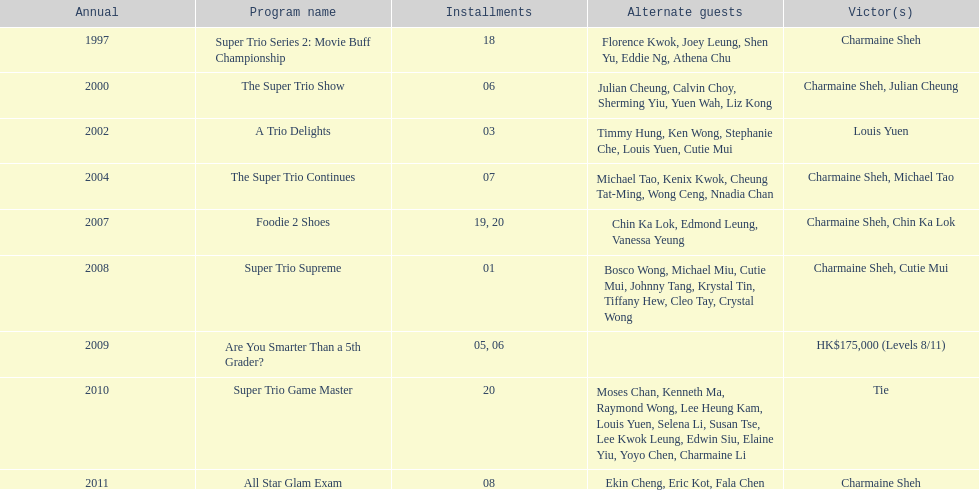What year was the only year were a tie occurred? 2010. 